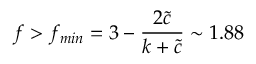Convert formula to latex. <formula><loc_0><loc_0><loc_500><loc_500>f > f _ { \min } = 3 - \frac { 2 { \tilde { c } } } { k + { \tilde { c } } } \sim 1 . 8 8 \,</formula> 